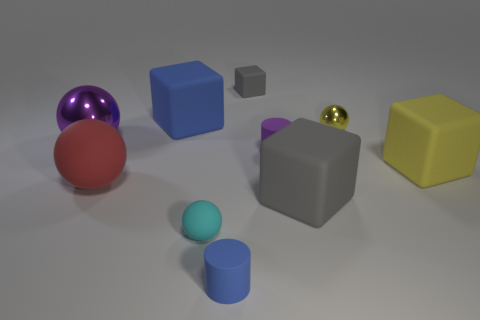Subtract all small yellow metal spheres. How many spheres are left? 3 Subtract 1 cylinders. How many cylinders are left? 1 Subtract all purple cylinders. How many cylinders are left? 1 Subtract all gray cubes. Subtract all yellow cylinders. How many cubes are left? 2 Subtract all yellow cubes. How many green spheres are left? 0 Subtract all tiny purple matte cylinders. Subtract all large spheres. How many objects are left? 7 Add 3 large yellow cubes. How many large yellow cubes are left? 4 Add 10 small red metal blocks. How many small red metal blocks exist? 10 Subtract 0 cyan cylinders. How many objects are left? 10 Subtract all spheres. How many objects are left? 6 